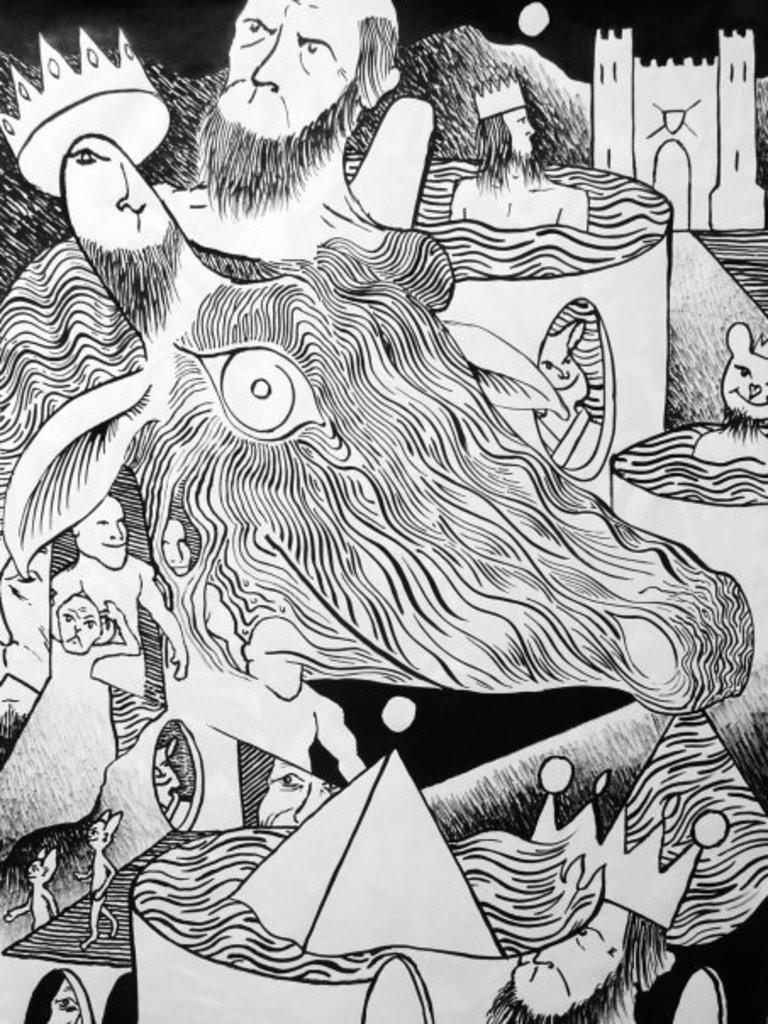What is the main subject of the image? The main subject of the image is a sketch. What can be said about the color scheme of the sketch? The color of the sketch is black and white. What type of map can be seen in the image? There is no map present in the image; it features a black and white sketch. What color is the cable used in the sketch? There is no cable present in the sketch, as it is a black and white sketch without any additional elements. 